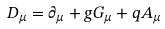<formula> <loc_0><loc_0><loc_500><loc_500>D _ { \mu } = \partial _ { \mu } + g G _ { \mu } + q A _ { \mu }</formula> 